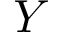Convert formula to latex. <formula><loc_0><loc_0><loc_500><loc_500>Y</formula> 